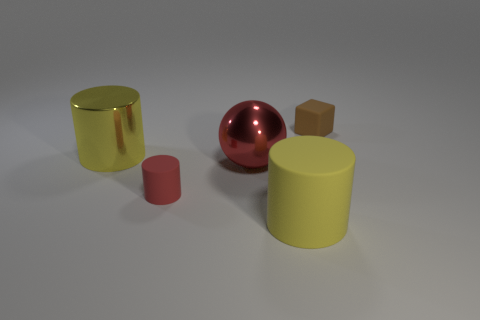Add 5 tiny purple metallic objects. How many objects exist? 10 Subtract all cylinders. How many objects are left? 2 Add 4 large red metallic things. How many large red metallic things exist? 5 Subtract 0 cyan cylinders. How many objects are left? 5 Subtract all yellow shiny objects. Subtract all red things. How many objects are left? 2 Add 4 tiny objects. How many tiny objects are left? 6 